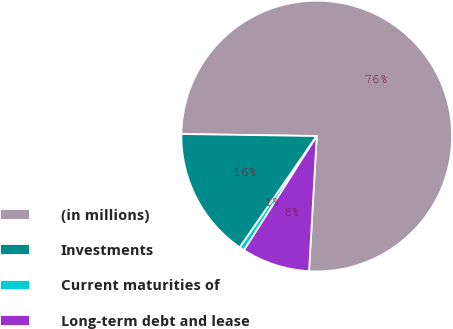<chart> <loc_0><loc_0><loc_500><loc_500><pie_chart><fcel>(in millions)<fcel>Investments<fcel>Current maturities of<fcel>Long-term debt and lease<nl><fcel>75.67%<fcel>15.62%<fcel>0.6%<fcel>8.11%<nl></chart> 